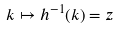Convert formula to latex. <formula><loc_0><loc_0><loc_500><loc_500>k \mapsto h ^ { - 1 } ( k ) = z</formula> 